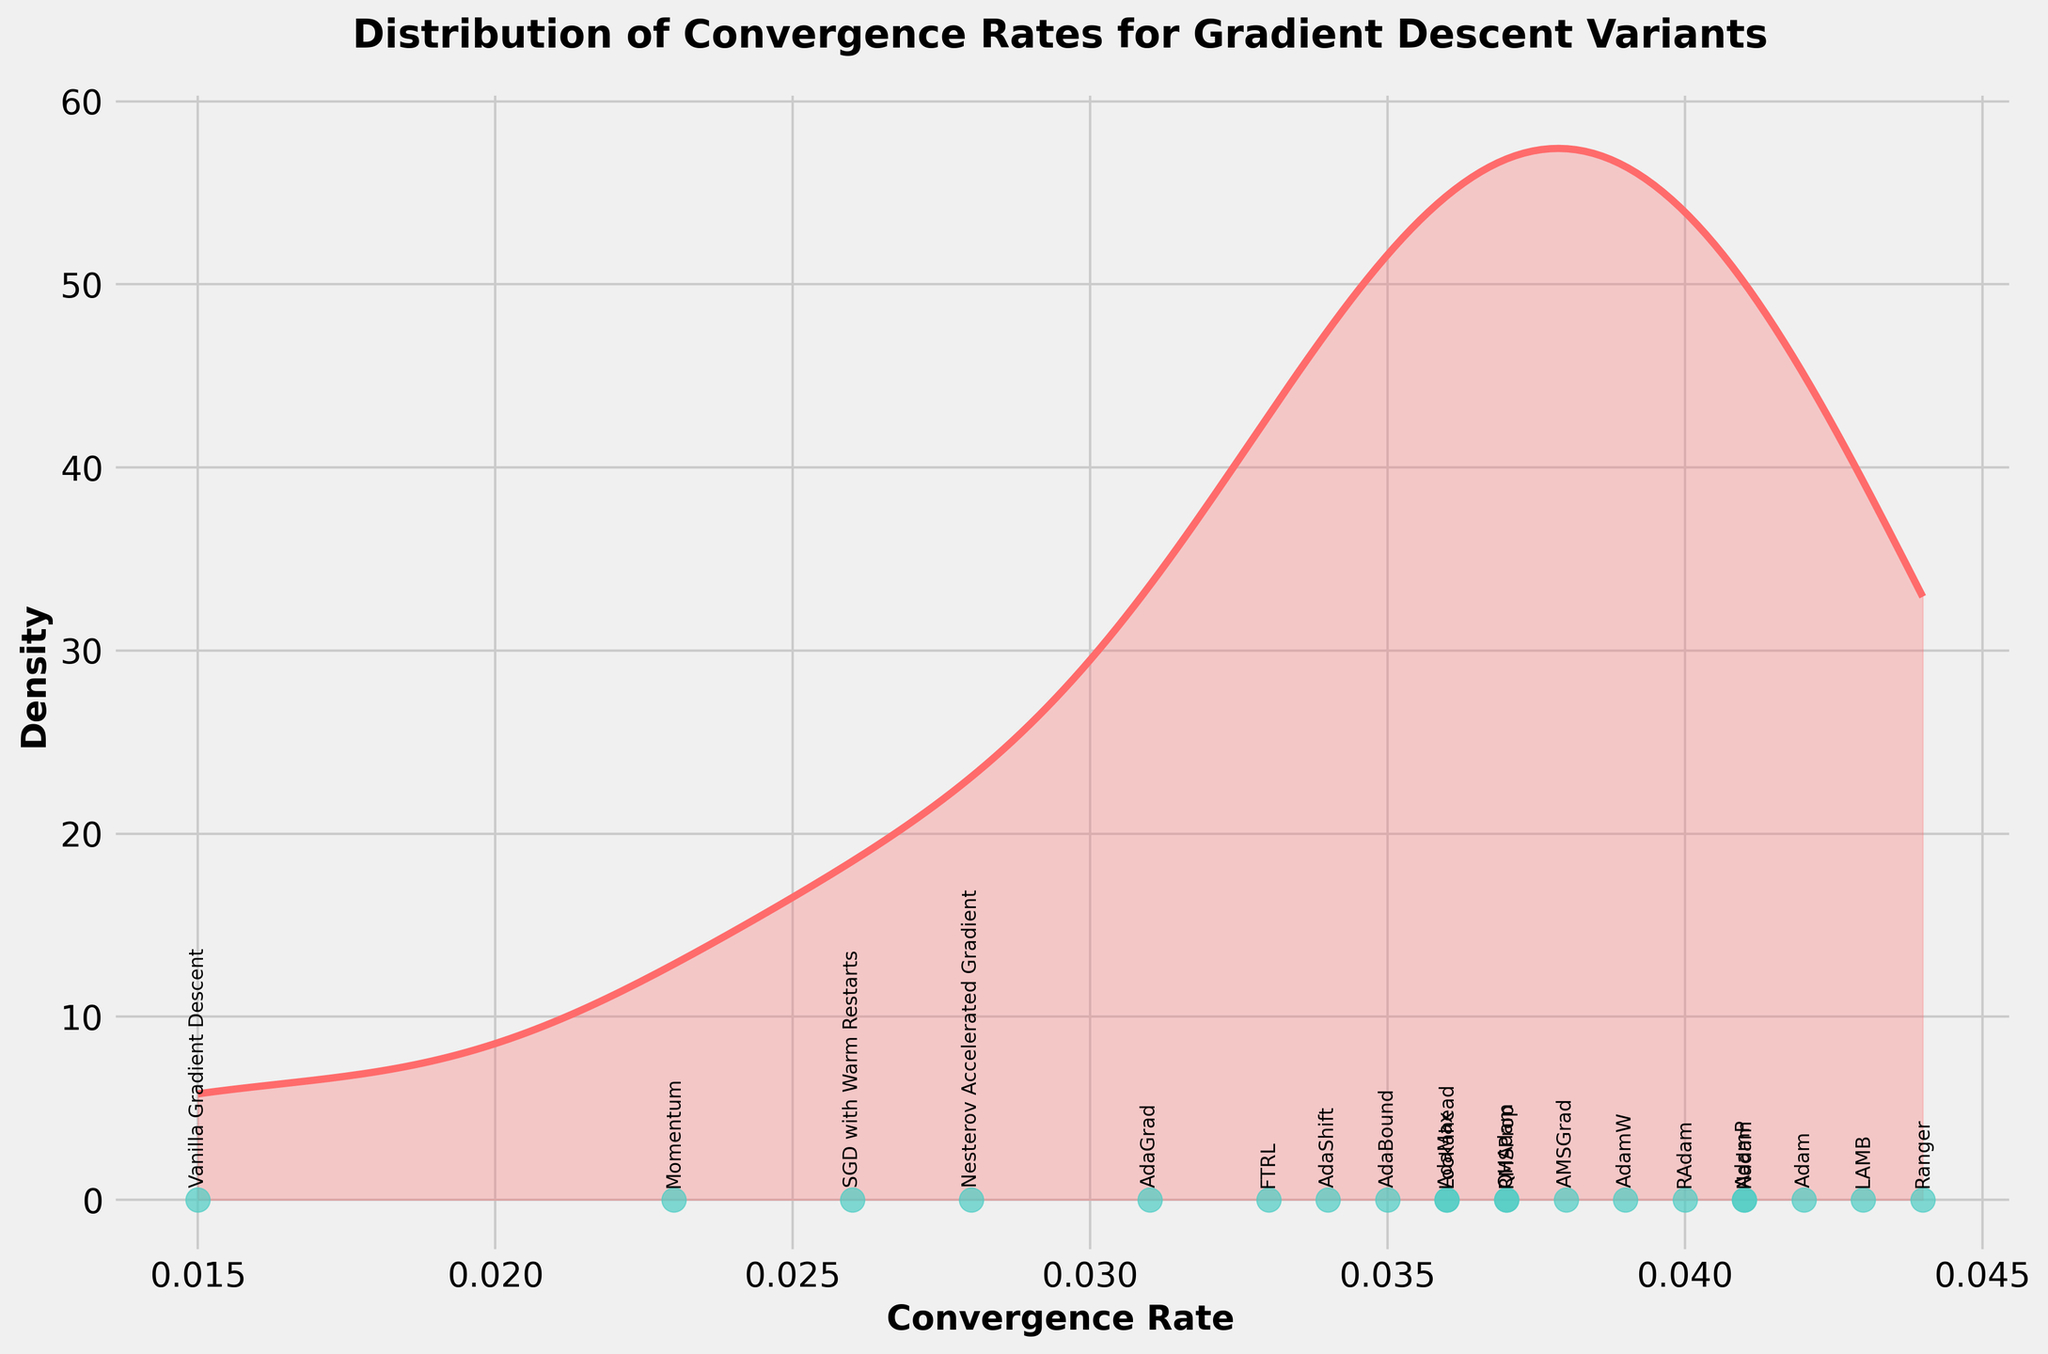What's the title of the figure? The title is displayed at the top of the figure.
Answer: Distribution of Convergence Rates for Gradient Descent Variants What do the x-axis and y-axis represent? The x-axis is labeled "Convergence Rate," representing the convergence rates of different gradient descent variants, and the y-axis is labeled "Density," representing the probability density of these rates.
Answer: Convergence Rate and Density Which algorithm has the highest convergence rate? By examining the labeled points on the x-axis, we identify the highest value.
Answer: Ranger How many algorithms have a convergence rate higher than 0.04? Identify and count the points labeled with convergence rates higher than 0.04 on the x-axis.
Answer: Four Which gradient descent variant has a lower convergence rate, Vanilla Gradient Descent or SGDW with Warm Restarts? Compare the convergence rates of Vanilla Gradient Descent and SGD with Warm Restarts by looking at their positions on the x-axis.
Answer: Vanilla Gradient Descent What is the approximate density value at a convergence rate of 0.035? Locate the convergence rate of 0.035 on the x-axis and read the corresponding density value from the y-axis.
Answer: ~2.4 What is the average convergence rate of the algorithms? Add the convergence rates of all the algorithms and divide by the number of algorithms. For the 19 algorithms listed, the calculation is (0.015+0.023+0.028+0.031+0.037+0.042+0.039+0.041+0.038+0.033+0.026+0.035+0.040+0.036+0.043+0.044+0.037+0.034+0.036)/19.
Answer: 0.0348 Are the convergence rates mostly clustered towards lower values, higher values, or evenly distributed? Examine the shape of the density plot; if it skews towards lower values, higher values, or is relatively symmetric.
Answer: Clustered towards higher values Given the density peak at around 0.035, which algorithms are likely contributing to this peak? Identify the algorithms whose convergence rates are near 0.035, considering those rates within a reasonable range around the peak.
Answer: AdaBound, AdaShift, RMSProp, QHAdam, AdaMax What's the median convergence rate of the algorithms? Sort the convergence rates and find the middle value. For an odd number of values, it’s the middle one; for an even number, it's the average of the two middle values. Here, the middle value (10th out of 19) is 0.036.
Answer: 0.036 